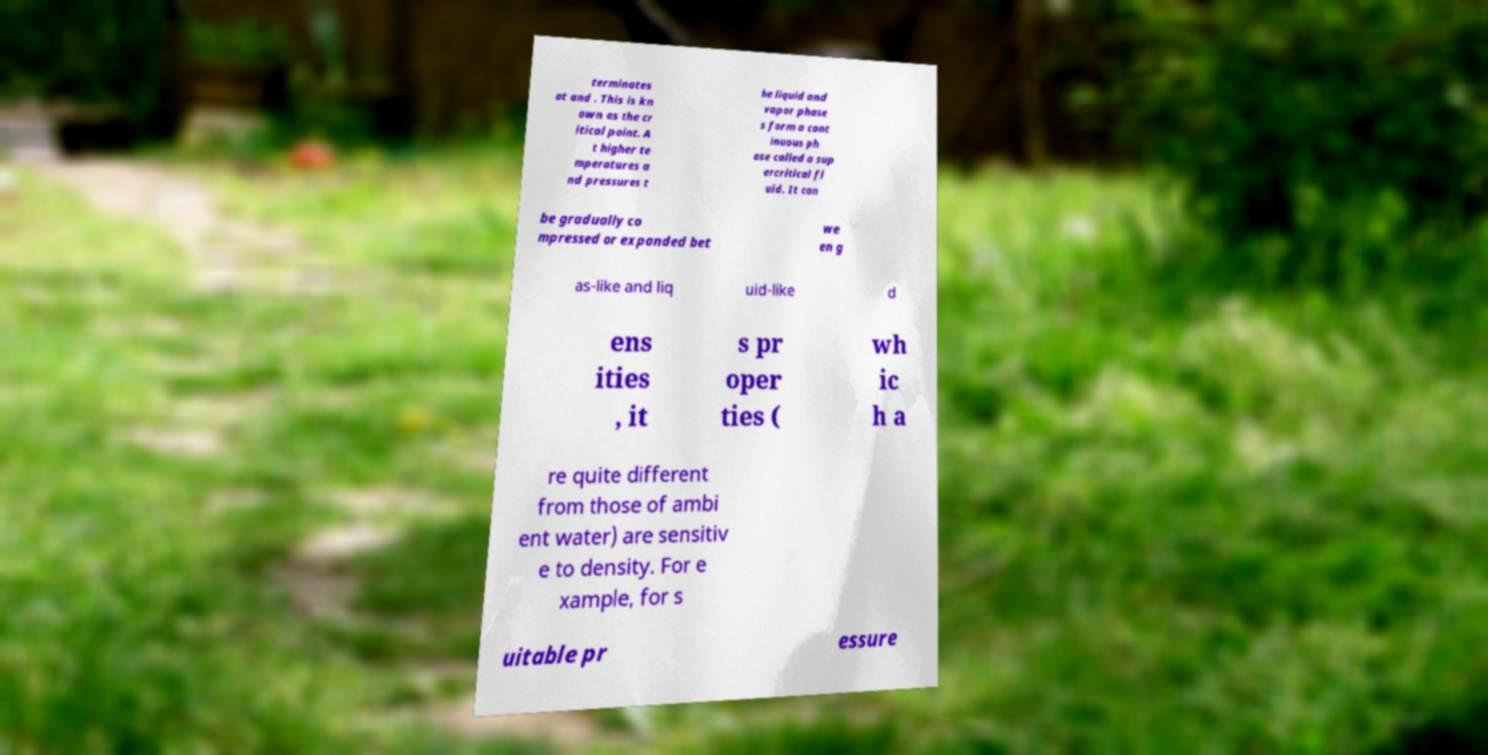There's text embedded in this image that I need extracted. Can you transcribe it verbatim? terminates at and . This is kn own as the cr itical point. A t higher te mperatures a nd pressures t he liquid and vapor phase s form a cont inuous ph ase called a sup ercritical fl uid. It can be gradually co mpressed or expanded bet we en g as-like and liq uid-like d ens ities , it s pr oper ties ( wh ic h a re quite different from those of ambi ent water) are sensitiv e to density. For e xample, for s uitable pr essure 